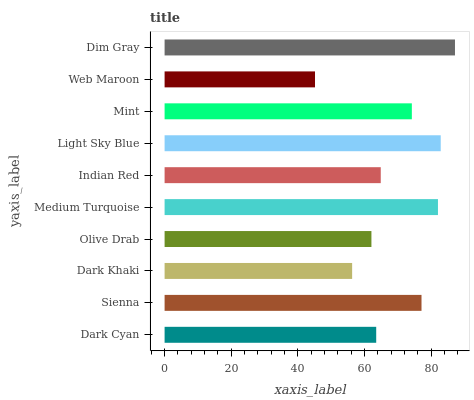Is Web Maroon the minimum?
Answer yes or no. Yes. Is Dim Gray the maximum?
Answer yes or no. Yes. Is Sienna the minimum?
Answer yes or no. No. Is Sienna the maximum?
Answer yes or no. No. Is Sienna greater than Dark Cyan?
Answer yes or no. Yes. Is Dark Cyan less than Sienna?
Answer yes or no. Yes. Is Dark Cyan greater than Sienna?
Answer yes or no. No. Is Sienna less than Dark Cyan?
Answer yes or no. No. Is Mint the high median?
Answer yes or no. Yes. Is Indian Red the low median?
Answer yes or no. Yes. Is Web Maroon the high median?
Answer yes or no. No. Is Medium Turquoise the low median?
Answer yes or no. No. 